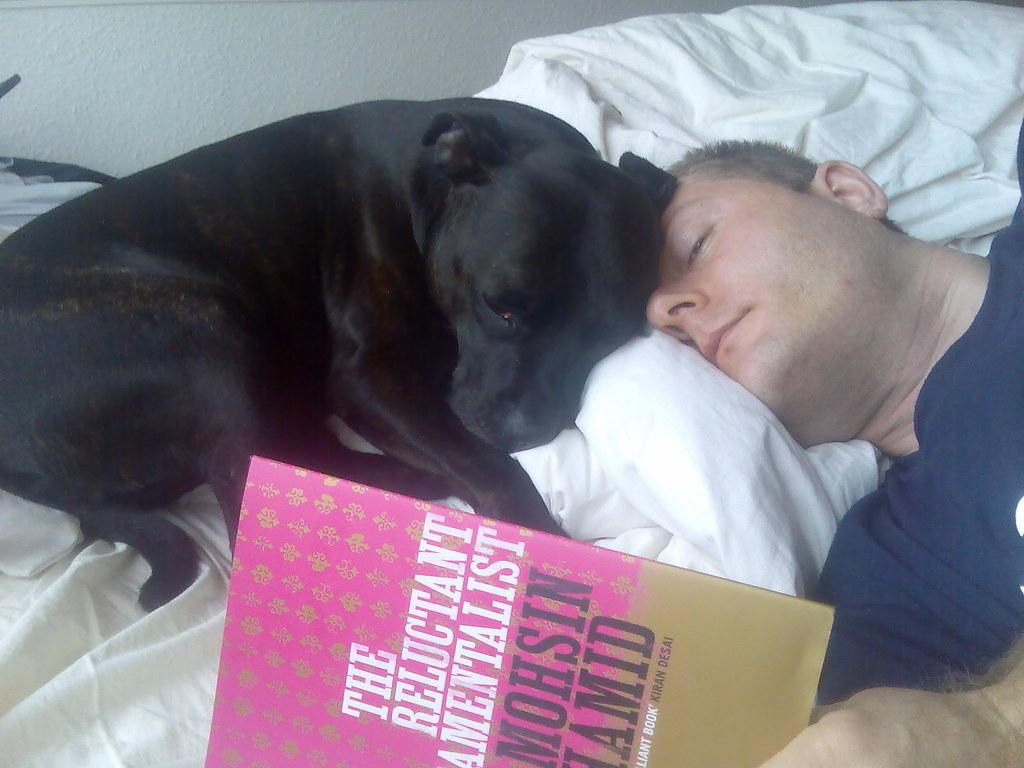What is the man in the image doing? The man is sleeping on the bed. What object is on the bed besides the man? There is a book on the bed. What other living creature is on the bed? There is a dog on the bed. What can be seen in the background of the image? There is a wall visible in the image. What type of drain can be seen in the image? There is no drain present in the image. What kind of pot is being used for the argument in the image? There is no argument or pot present in the image. 